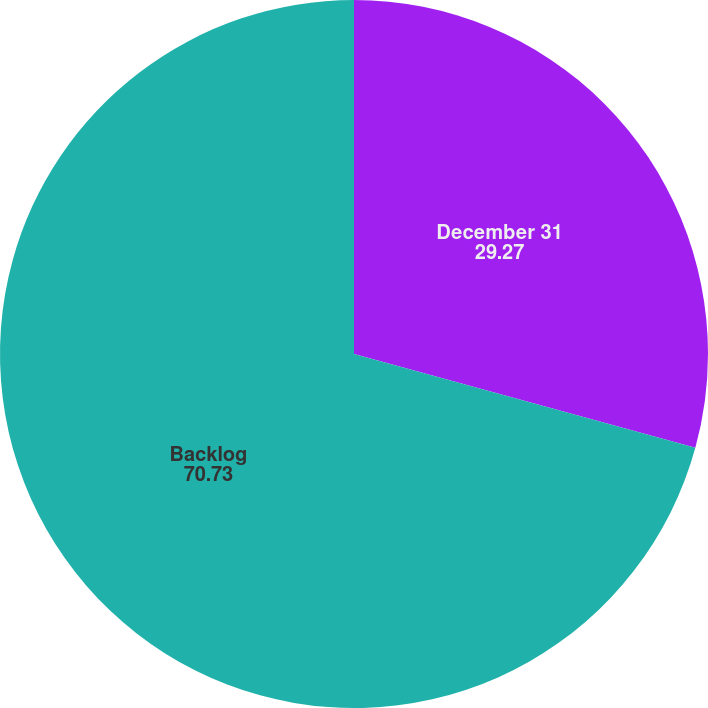Convert chart to OTSL. <chart><loc_0><loc_0><loc_500><loc_500><pie_chart><fcel>December 31<fcel>Backlog<nl><fcel>29.27%<fcel>70.73%<nl></chart> 